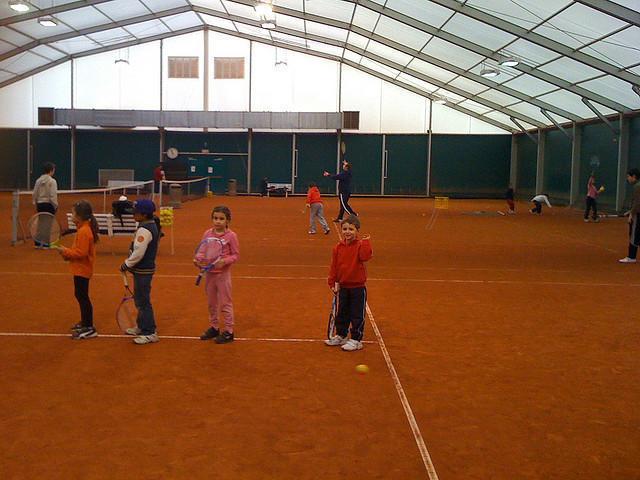How many are playing the game?
Give a very brief answer. 4. How many people are there?
Give a very brief answer. 4. 